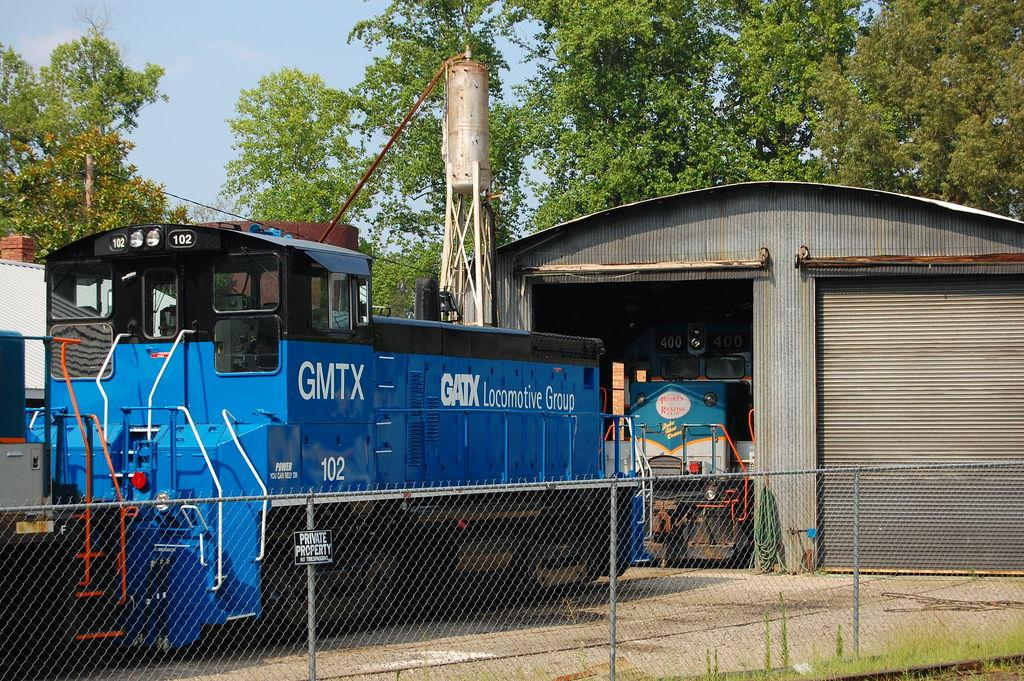What is located in the foreground of the image? In the foreground of the image, there is a net boundary, a shed, a tower, and trains. Can you describe the structures in the foreground? The shed and tower are both visible in the foreground, along with the net boundary and trains. What can be seen in the background of the image? In the background of the image, there are trees, another shed, and the sky. How many sheds are visible in the image? There are two sheds visible in the image, one in the foreground and another in the background. What type of nail is being hammered into the tower in the image? There is no nail being hammered into the tower in the image. How many planes can be seen flying in the sky in the image? There are no planes visible in the sky in the image. 